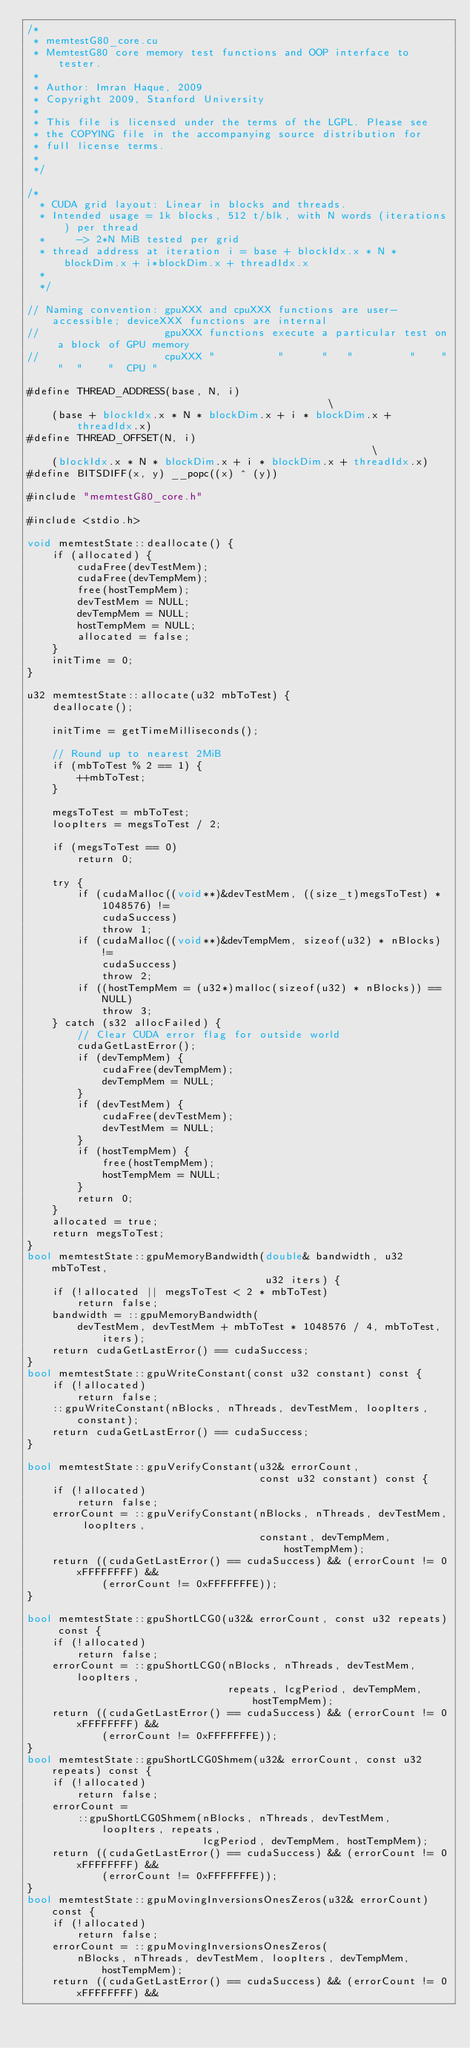<code> <loc_0><loc_0><loc_500><loc_500><_Cuda_>/*
 * memtestG80_core.cu
 * MemtestG80 core memory test functions and OOP interface to tester.
 *
 * Author: Imran Haque, 2009
 * Copyright 2009, Stanford University
 *
 * This file is licensed under the terms of the LGPL. Please see
 * the COPYING file in the accompanying source distribution for
 * full license terms.
 *
 */

/*
  * CUDA grid layout: Linear in blocks and threads.
  * Intended usage = 1k blocks, 512 t/blk, with N words (iterations) per thread
  *     -> 2*N MiB tested per grid
  * thread address at iteration i = base + blockIdx.x * N * blockDim.x + i*blockDim.x + threadIdx.x
  *
  */

// Naming convention: gpuXXX and cpuXXX functions are user-accessible; deviceXXX functions are internal
//                    gpuXXX functions execute a particular test on a block of GPU memory
//                    cpuXXX "          "      "   "         "    " "  "    "  CPU "

#define THREAD_ADDRESS(base, N, i)                                             \
    (base + blockIdx.x * N * blockDim.x + i * blockDim.x + threadIdx.x)
#define THREAD_OFFSET(N, i)                                                    \
    (blockIdx.x * N * blockDim.x + i * blockDim.x + threadIdx.x)
#define BITSDIFF(x, y) __popc((x) ^ (y))

#include "memtestG80_core.h"

#include <stdio.h>

void memtestState::deallocate() {
    if (allocated) {
        cudaFree(devTestMem);
        cudaFree(devTempMem);
        free(hostTempMem);
        devTestMem = NULL;
        devTempMem = NULL;
        hostTempMem = NULL;
        allocated = false;
    }
    initTime = 0;
}

u32 memtestState::allocate(u32 mbToTest) {
    deallocate();

    initTime = getTimeMilliseconds();

    // Round up to nearest 2MiB
    if (mbToTest % 2 == 1) {
        ++mbToTest;
    }

    megsToTest = mbToTest;
    loopIters = megsToTest / 2;

    if (megsToTest == 0)
        return 0;

    try {
        if (cudaMalloc((void**)&devTestMem, ((size_t)megsToTest) * 1048576) !=
            cudaSuccess)
            throw 1;
        if (cudaMalloc((void**)&devTempMem, sizeof(u32) * nBlocks) !=
            cudaSuccess)
            throw 2;
        if ((hostTempMem = (u32*)malloc(sizeof(u32) * nBlocks)) == NULL)
            throw 3;
    } catch (s32 allocFailed) {
        // Clear CUDA error flag for outside world
        cudaGetLastError();
        if (devTempMem) {
            cudaFree(devTempMem);
            devTempMem = NULL;
        }
        if (devTestMem) {
            cudaFree(devTestMem);
            devTestMem = NULL;
        }
        if (hostTempMem) {
            free(hostTempMem);
            hostTempMem = NULL;
        }
        return 0;
    }
    allocated = true;
    return megsToTest;
}
bool memtestState::gpuMemoryBandwidth(double& bandwidth, u32 mbToTest,
                                      u32 iters) {
    if (!allocated || megsToTest < 2 * mbToTest)
        return false;
    bandwidth = ::gpuMemoryBandwidth(
        devTestMem, devTestMem + mbToTest * 1048576 / 4, mbToTest, iters);
    return cudaGetLastError() == cudaSuccess;
}
bool memtestState::gpuWriteConstant(const u32 constant) const {
    if (!allocated)
        return false;
    ::gpuWriteConstant(nBlocks, nThreads, devTestMem, loopIters, constant);
    return cudaGetLastError() == cudaSuccess;
}

bool memtestState::gpuVerifyConstant(u32& errorCount,
                                     const u32 constant) const {
    if (!allocated)
        return false;
    errorCount = ::gpuVerifyConstant(nBlocks, nThreads, devTestMem, loopIters,
                                     constant, devTempMem, hostTempMem);
    return ((cudaGetLastError() == cudaSuccess) && (errorCount != 0xFFFFFFFF) &&
            (errorCount != 0xFFFFFFFE));
}

bool memtestState::gpuShortLCG0(u32& errorCount, const u32 repeats) const {
    if (!allocated)
        return false;
    errorCount = ::gpuShortLCG0(nBlocks, nThreads, devTestMem, loopIters,
                                repeats, lcgPeriod, devTempMem, hostTempMem);
    return ((cudaGetLastError() == cudaSuccess) && (errorCount != 0xFFFFFFFF) &&
            (errorCount != 0xFFFFFFFE));
}
bool memtestState::gpuShortLCG0Shmem(u32& errorCount, const u32 repeats) const {
    if (!allocated)
        return false;
    errorCount =
        ::gpuShortLCG0Shmem(nBlocks, nThreads, devTestMem, loopIters, repeats,
                            lcgPeriod, devTempMem, hostTempMem);
    return ((cudaGetLastError() == cudaSuccess) && (errorCount != 0xFFFFFFFF) &&
            (errorCount != 0xFFFFFFFE));
}
bool memtestState::gpuMovingInversionsOnesZeros(u32& errorCount) const {
    if (!allocated)
        return false;
    errorCount = ::gpuMovingInversionsOnesZeros(
        nBlocks, nThreads, devTestMem, loopIters, devTempMem, hostTempMem);
    return ((cudaGetLastError() == cudaSuccess) && (errorCount != 0xFFFFFFFF) &&</code> 